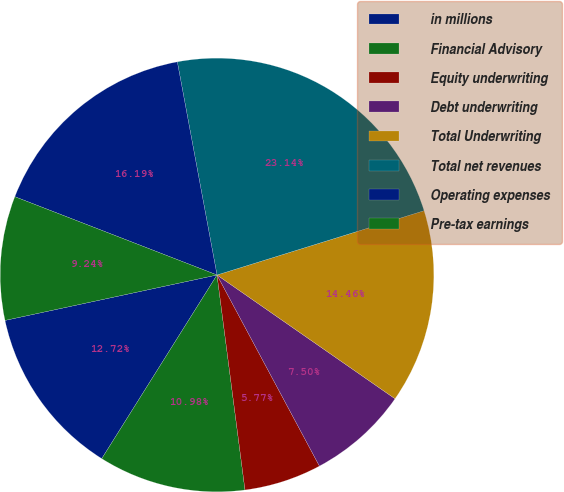<chart> <loc_0><loc_0><loc_500><loc_500><pie_chart><fcel>in millions<fcel>Financial Advisory<fcel>Equity underwriting<fcel>Debt underwriting<fcel>Total Underwriting<fcel>Total net revenues<fcel>Operating expenses<fcel>Pre-tax earnings<nl><fcel>12.72%<fcel>10.98%<fcel>5.77%<fcel>7.5%<fcel>14.46%<fcel>23.14%<fcel>16.19%<fcel>9.24%<nl></chart> 